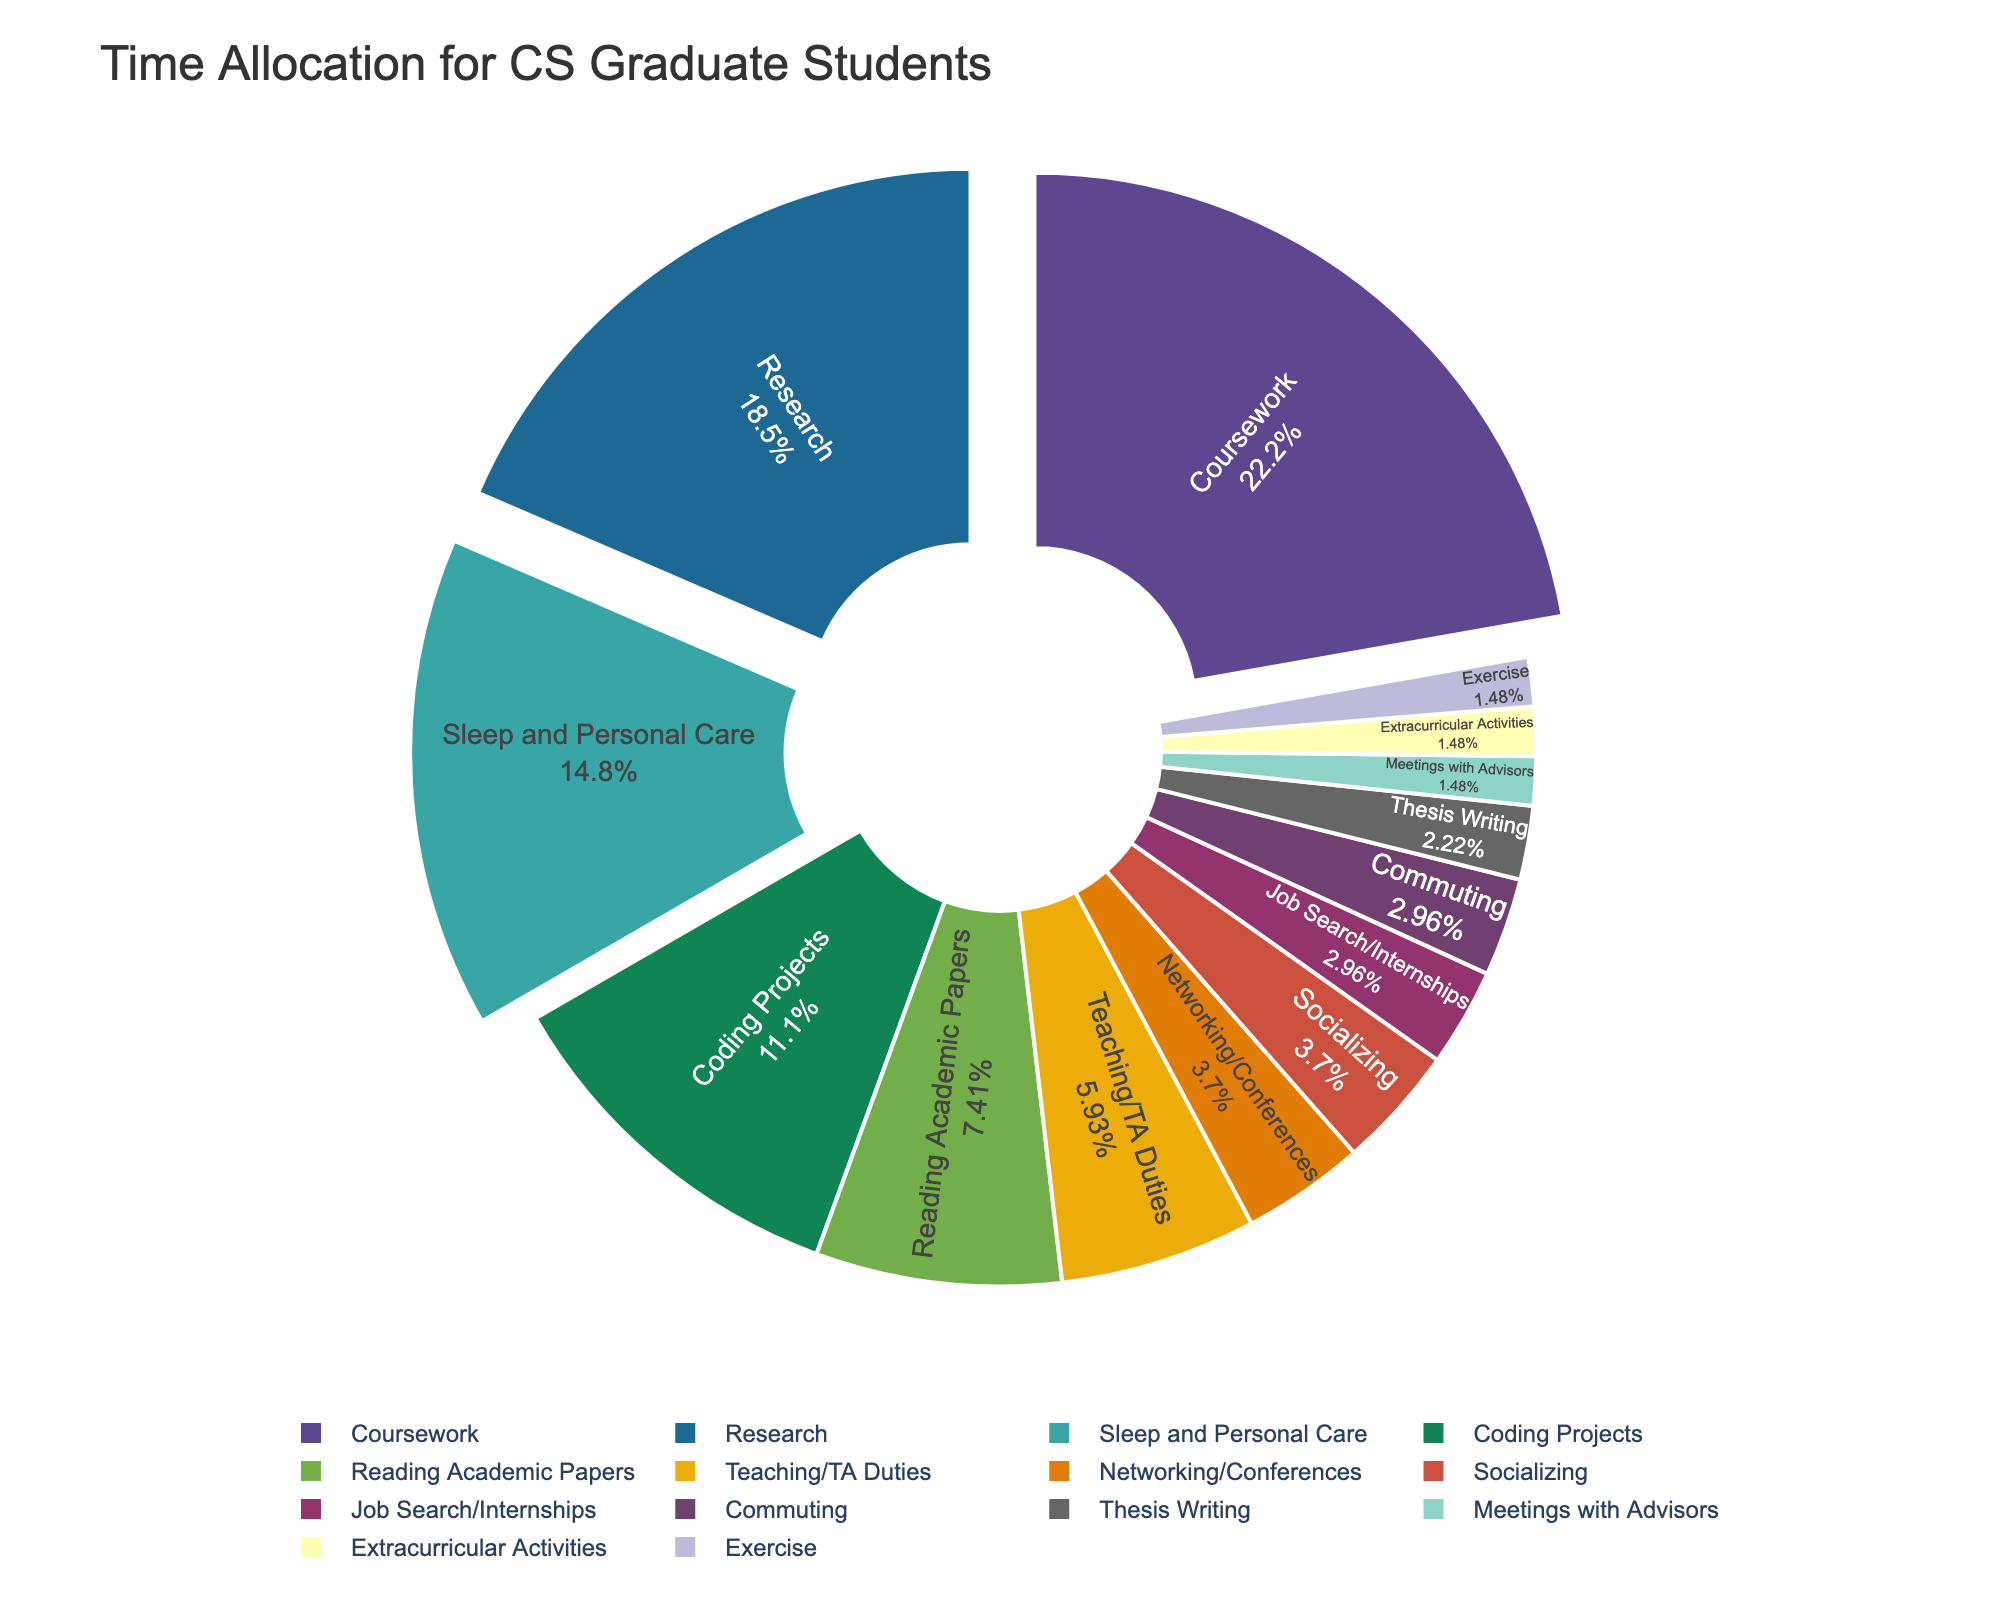What's the most time-consuming activity for CS graduate students? The pie chart shows various activities. The largest slice represents the time spent on "Coursework," which is 30%.
Answer: Coursework Which two activities combined account for 35% of the time allocation? Adding the percentages for "Research" (25%) and "Coding Projects" (15%) gives a total of 40%, which is greater than 35%. Instead, adding "Research" (25%) and "Reading Academic Papers" (10%) gives exactly 35%.
Answer: Research and Reading Academic Papers What is the difference in percentage between time spent on socializing and time spent on teaching/TA duties? The pie chart shows "Socializing" at 5% and "Teaching/TA Duties" at 8%. Subtracting these gives 8% - 5% = 3%.
Answer: 3% Do CS graduate students spend more time on extracurricular activities or exercising? The pie chart shows both "Extracurricular Activities" and "Exercise" at 2%, meaning they spend an equal amount of time on both activities.
Answer: Equal Which three activities make up the smallest time allocations? The smallest percentages on the pie chart are "Thesis Writing" (3%), "Meetings with Advisors" (2%), and "Extracurricular Activities" (2%) or "Exercise" (2%).
Answer: Thesis Writing, Meetings with Advisors, and Extracurricular Activities or Exercise How much more time is spent on coursework compared to reading academic papers? The pie chart shows "Coursework" at 30% and "Reading Academic Papers" at 10%. The difference is 30% - 10% = 20%.
Answer: 20% Is more time spent on sleep and personal care or on coding projects? The pie chart shows "Sleep and Personal Care" at 20% and "Coding Projects" at 15%. Clearly, more time is spent on "Sleep and Personal Care".
Answer: Sleep and Personal Care What is the total percentage of time spent on research, teaching/TA duties, and job search/internships combined? Summing the percentages from the pie chart: "Research" (25%), "Teaching/TA Duties" (8%), and "Job Search/Internships" (4%) gives a total of 25% + 8% + 4% = 37%.
Answer: 37% Which activity has a larger portion: Networking/Conferences or Commuting? According to the pie chart, "Networking/Conferences" is 5% while "Commuting" is 4%. Therefore, "Networking/Conferences" has a larger portion.
Answer: Networking/Conferences 